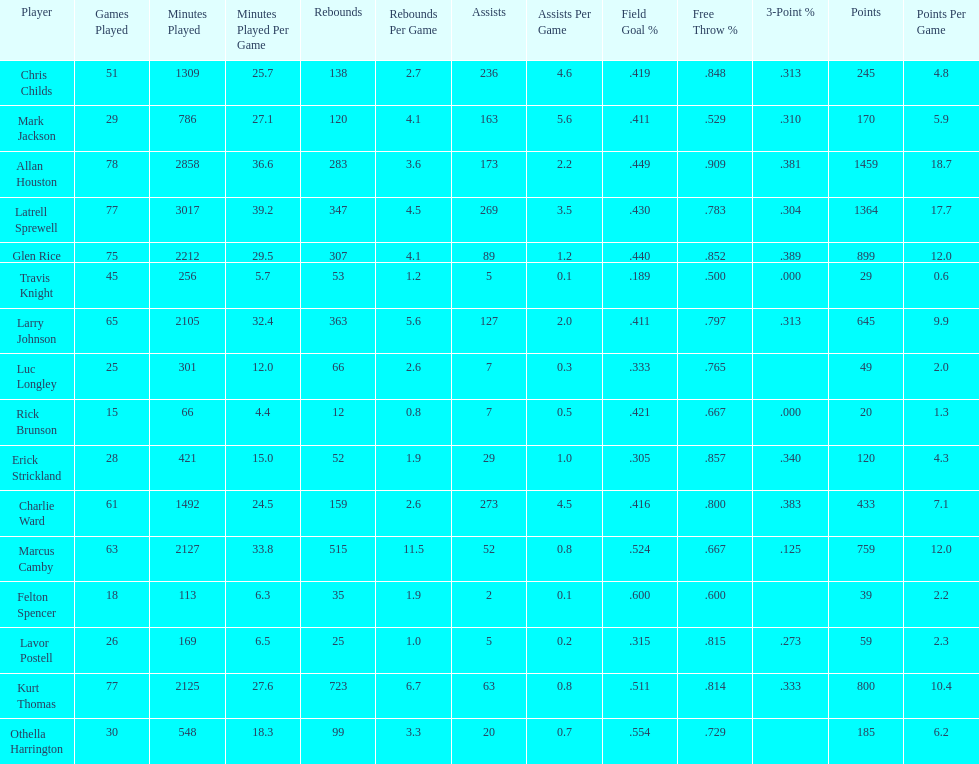How many more games did allan houston play than mark jackson? 49. 